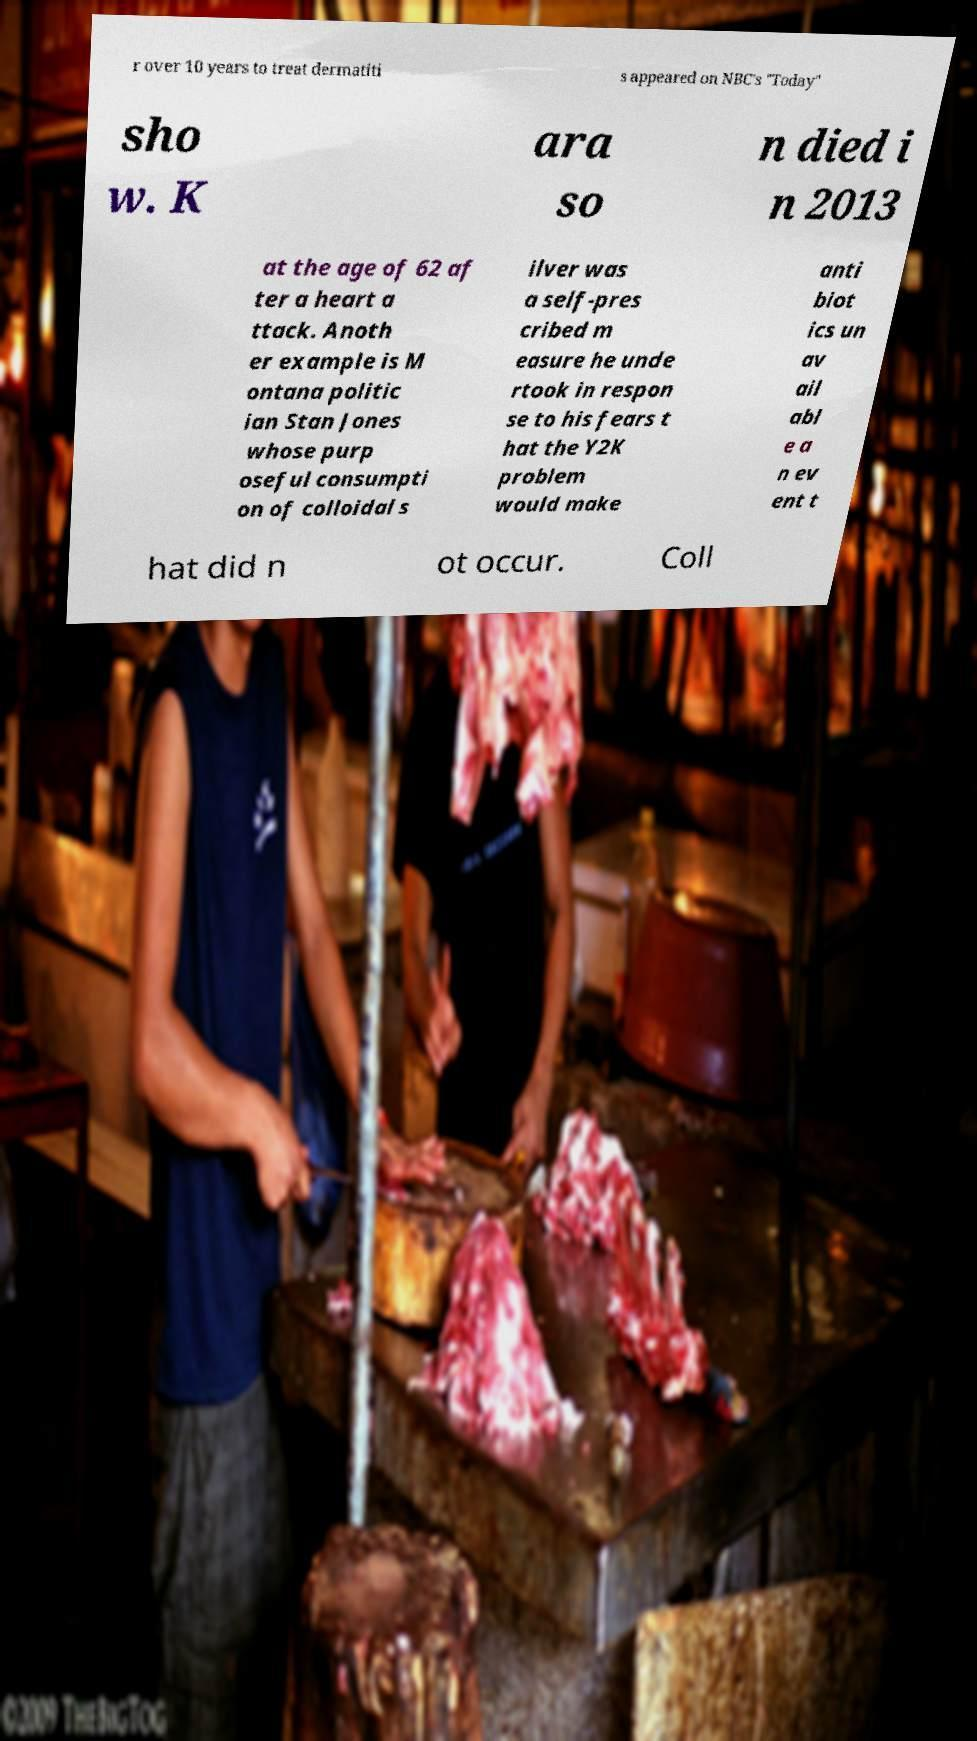Could you assist in decoding the text presented in this image and type it out clearly? r over 10 years to treat dermatiti s appeared on NBC's "Today" sho w. K ara so n died i n 2013 at the age of 62 af ter a heart a ttack. Anoth er example is M ontana politic ian Stan Jones whose purp oseful consumpti on of colloidal s ilver was a self-pres cribed m easure he unde rtook in respon se to his fears t hat the Y2K problem would make anti biot ics un av ail abl e a n ev ent t hat did n ot occur. Coll 